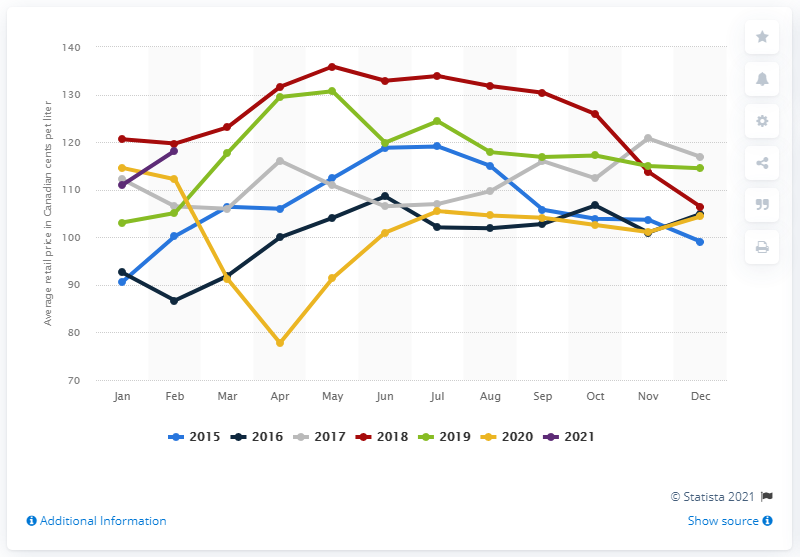Indicate a few pertinent items in this graphic. The average retail price of gasoline at self-service stations in Canada in February 2021 was $118.2 per gallon. 